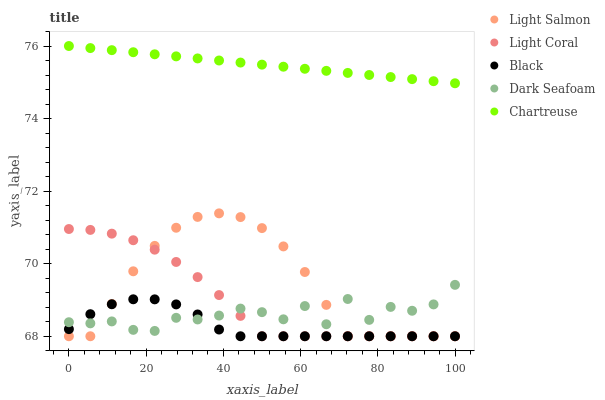Does Black have the minimum area under the curve?
Answer yes or no. Yes. Does Chartreuse have the maximum area under the curve?
Answer yes or no. Yes. Does Light Salmon have the minimum area under the curve?
Answer yes or no. No. Does Light Salmon have the maximum area under the curve?
Answer yes or no. No. Is Chartreuse the smoothest?
Answer yes or no. Yes. Is Dark Seafoam the roughest?
Answer yes or no. Yes. Is Light Salmon the smoothest?
Answer yes or no. No. Is Light Salmon the roughest?
Answer yes or no. No. Does Light Coral have the lowest value?
Answer yes or no. Yes. Does Dark Seafoam have the lowest value?
Answer yes or no. No. Does Chartreuse have the highest value?
Answer yes or no. Yes. Does Light Salmon have the highest value?
Answer yes or no. No. Is Dark Seafoam less than Chartreuse?
Answer yes or no. Yes. Is Chartreuse greater than Black?
Answer yes or no. Yes. Does Light Salmon intersect Black?
Answer yes or no. Yes. Is Light Salmon less than Black?
Answer yes or no. No. Is Light Salmon greater than Black?
Answer yes or no. No. Does Dark Seafoam intersect Chartreuse?
Answer yes or no. No. 